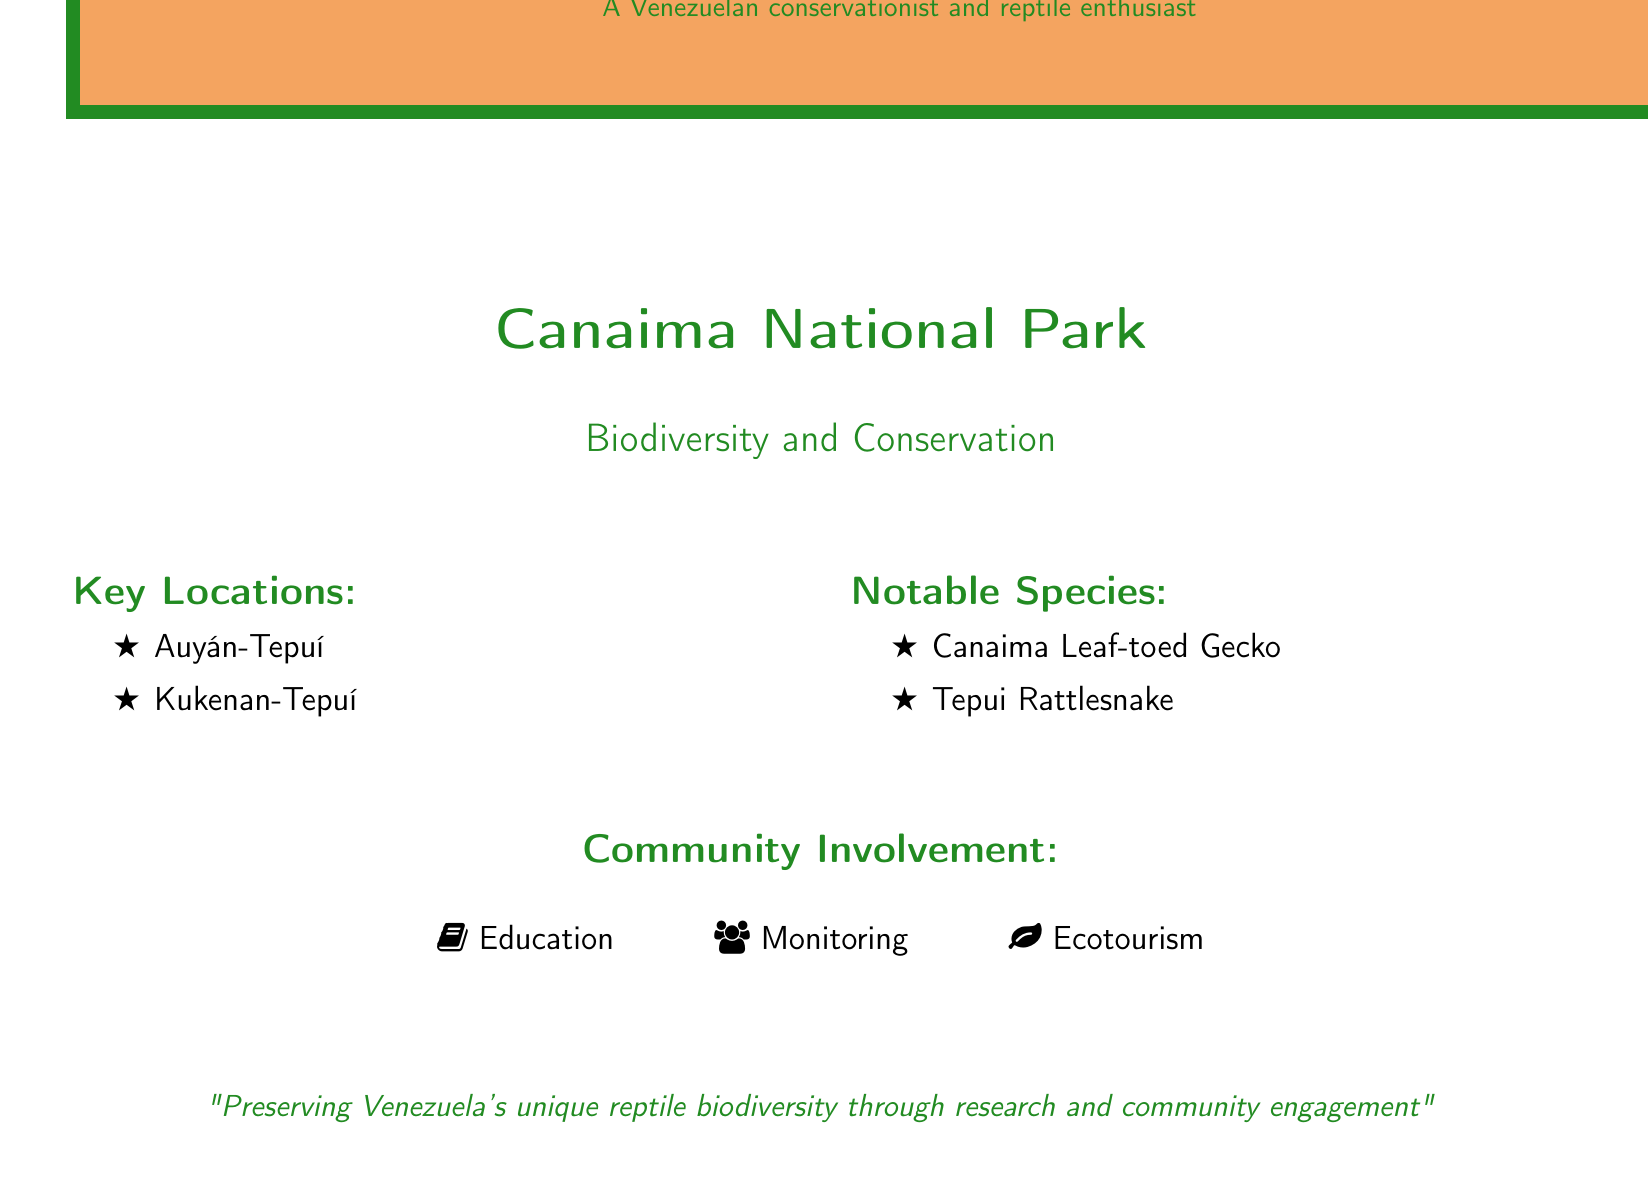What are the key locations mentioned? The document lists key locations in Canaima National Park, which are Auyán-Tepuí and Kukenan-Tepuí.
Answer: Auyán-Tepuí, Kukenan-Tepuí What is a notable species found in the park? The document specifies notable species in the park, including the Canaima Leaf-toed Gecko and the Tepui Rattlesnake.
Answer: Canaima Leaf-toed Gecko How is community involvement categorized? The document outlines community involvement in three categories: Education, Monitoring, and Ecotourism.
Answer: Education, Monitoring, Ecotourism What color is used for the "Field Report Envelope"? The document design indicates that the envelope has a color scheme highlighted with reptile green.
Answer: reptile green Which conservation action is suggested regarding local communities? The document emphasizes the importance of community engagement in preserving biodiversity through education and involvement.
Answer: Community engagement How many notable species are listed in the report? The document provides a count of notable species mentioned, which is two.
Answer: Two What is the main focus of the field report? The document highlights the focus on preserving Venezuela's unique reptile biodiversity through research and community engagement.
Answer: Preserving Venezuela's unique reptile biodiversity What type of document is this? The format and content of the document suggest that it is a field report focused on biodiversity and conservation in Canaima National Park.
Answer: Field report 